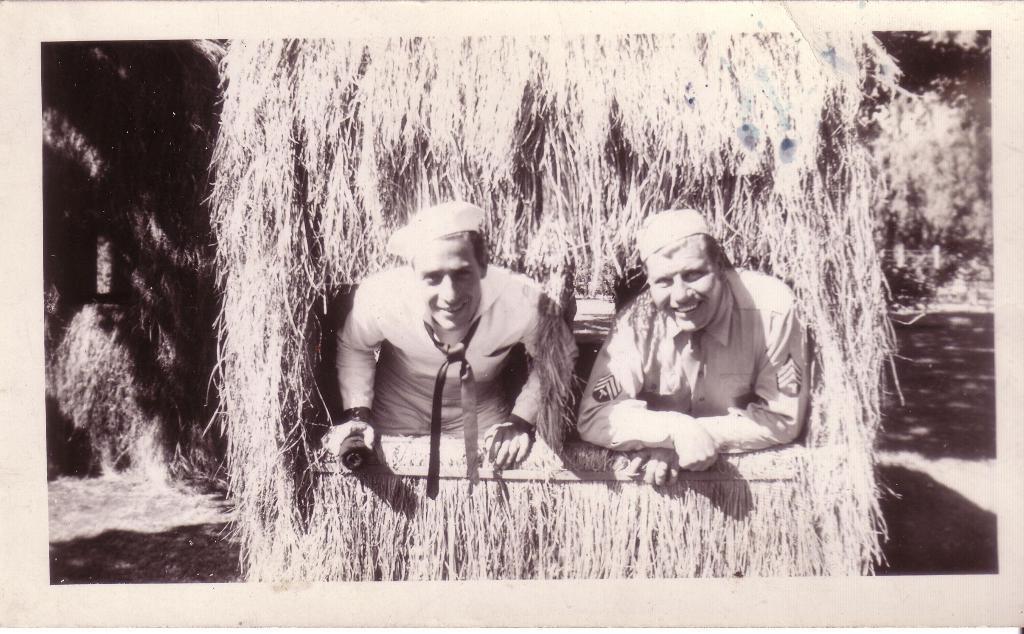Describe this image in one or two sentences. As we can see in the image there is a vehicle, dry grass and two people wearing white color shirts. 